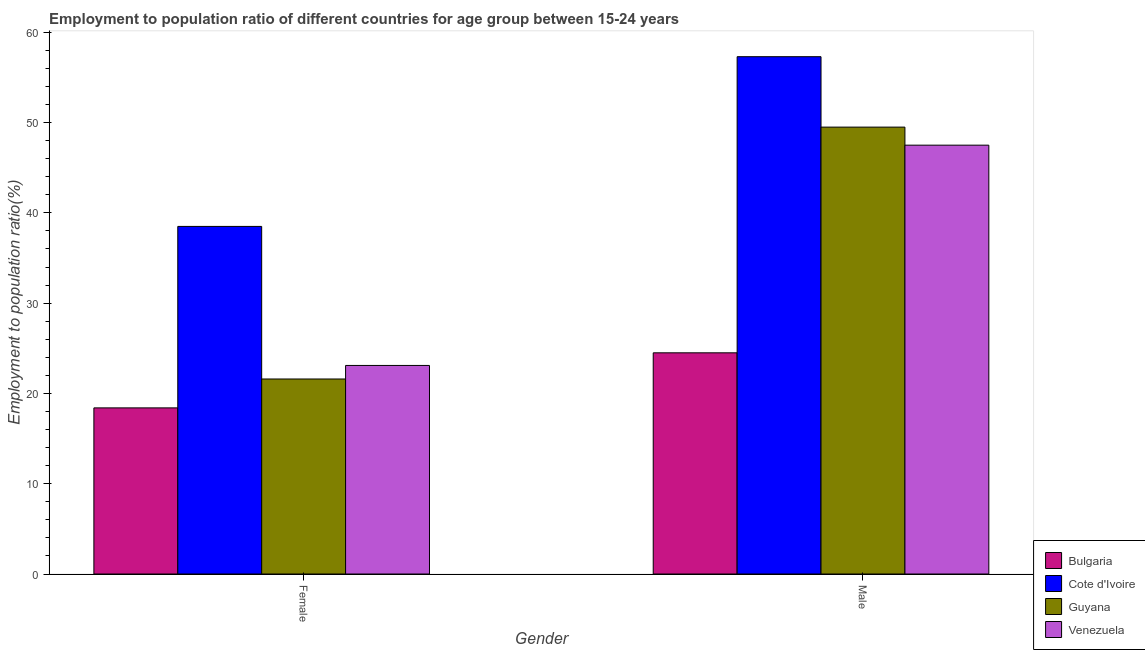How many different coloured bars are there?
Your response must be concise. 4. What is the label of the 2nd group of bars from the left?
Ensure brevity in your answer.  Male. What is the employment to population ratio(female) in Cote d'Ivoire?
Your response must be concise. 38.5. Across all countries, what is the maximum employment to population ratio(female)?
Give a very brief answer. 38.5. In which country was the employment to population ratio(male) maximum?
Keep it short and to the point. Cote d'Ivoire. What is the total employment to population ratio(female) in the graph?
Ensure brevity in your answer.  101.6. What is the difference between the employment to population ratio(male) in Guyana and that in Venezuela?
Offer a terse response. 2. What is the difference between the employment to population ratio(male) in Venezuela and the employment to population ratio(female) in Guyana?
Make the answer very short. 25.9. What is the average employment to population ratio(female) per country?
Your answer should be compact. 25.4. What is the difference between the employment to population ratio(female) and employment to population ratio(male) in Bulgaria?
Ensure brevity in your answer.  -6.1. In how many countries, is the employment to population ratio(female) greater than 2 %?
Your answer should be compact. 4. What is the ratio of the employment to population ratio(female) in Bulgaria to that in Guyana?
Offer a very short reply. 0.85. What does the 4th bar from the left in Female represents?
Offer a terse response. Venezuela. What does the 3rd bar from the right in Male represents?
Provide a short and direct response. Cote d'Ivoire. How many bars are there?
Ensure brevity in your answer.  8. How many countries are there in the graph?
Keep it short and to the point. 4. What is the difference between two consecutive major ticks on the Y-axis?
Provide a succinct answer. 10. Are the values on the major ticks of Y-axis written in scientific E-notation?
Offer a very short reply. No. Where does the legend appear in the graph?
Give a very brief answer. Bottom right. What is the title of the graph?
Provide a succinct answer. Employment to population ratio of different countries for age group between 15-24 years. Does "East Asia (developing only)" appear as one of the legend labels in the graph?
Your answer should be compact. No. What is the label or title of the X-axis?
Your response must be concise. Gender. What is the Employment to population ratio(%) in Bulgaria in Female?
Your answer should be very brief. 18.4. What is the Employment to population ratio(%) of Cote d'Ivoire in Female?
Provide a short and direct response. 38.5. What is the Employment to population ratio(%) in Guyana in Female?
Make the answer very short. 21.6. What is the Employment to population ratio(%) in Venezuela in Female?
Your answer should be very brief. 23.1. What is the Employment to population ratio(%) in Cote d'Ivoire in Male?
Your answer should be very brief. 57.3. What is the Employment to population ratio(%) in Guyana in Male?
Ensure brevity in your answer.  49.5. What is the Employment to population ratio(%) of Venezuela in Male?
Provide a short and direct response. 47.5. Across all Gender, what is the maximum Employment to population ratio(%) in Bulgaria?
Keep it short and to the point. 24.5. Across all Gender, what is the maximum Employment to population ratio(%) in Cote d'Ivoire?
Your response must be concise. 57.3. Across all Gender, what is the maximum Employment to population ratio(%) in Guyana?
Offer a terse response. 49.5. Across all Gender, what is the maximum Employment to population ratio(%) in Venezuela?
Provide a short and direct response. 47.5. Across all Gender, what is the minimum Employment to population ratio(%) in Bulgaria?
Provide a succinct answer. 18.4. Across all Gender, what is the minimum Employment to population ratio(%) of Cote d'Ivoire?
Ensure brevity in your answer.  38.5. Across all Gender, what is the minimum Employment to population ratio(%) of Guyana?
Your answer should be compact. 21.6. Across all Gender, what is the minimum Employment to population ratio(%) of Venezuela?
Provide a succinct answer. 23.1. What is the total Employment to population ratio(%) in Bulgaria in the graph?
Provide a short and direct response. 42.9. What is the total Employment to population ratio(%) in Cote d'Ivoire in the graph?
Offer a terse response. 95.8. What is the total Employment to population ratio(%) in Guyana in the graph?
Your response must be concise. 71.1. What is the total Employment to population ratio(%) in Venezuela in the graph?
Give a very brief answer. 70.6. What is the difference between the Employment to population ratio(%) in Bulgaria in Female and that in Male?
Provide a succinct answer. -6.1. What is the difference between the Employment to population ratio(%) in Cote d'Ivoire in Female and that in Male?
Your answer should be compact. -18.8. What is the difference between the Employment to population ratio(%) of Guyana in Female and that in Male?
Give a very brief answer. -27.9. What is the difference between the Employment to population ratio(%) in Venezuela in Female and that in Male?
Offer a terse response. -24.4. What is the difference between the Employment to population ratio(%) of Bulgaria in Female and the Employment to population ratio(%) of Cote d'Ivoire in Male?
Keep it short and to the point. -38.9. What is the difference between the Employment to population ratio(%) of Bulgaria in Female and the Employment to population ratio(%) of Guyana in Male?
Offer a very short reply. -31.1. What is the difference between the Employment to population ratio(%) of Bulgaria in Female and the Employment to population ratio(%) of Venezuela in Male?
Give a very brief answer. -29.1. What is the difference between the Employment to population ratio(%) of Guyana in Female and the Employment to population ratio(%) of Venezuela in Male?
Offer a very short reply. -25.9. What is the average Employment to population ratio(%) in Bulgaria per Gender?
Offer a very short reply. 21.45. What is the average Employment to population ratio(%) of Cote d'Ivoire per Gender?
Your answer should be very brief. 47.9. What is the average Employment to population ratio(%) of Guyana per Gender?
Make the answer very short. 35.55. What is the average Employment to population ratio(%) of Venezuela per Gender?
Your answer should be very brief. 35.3. What is the difference between the Employment to population ratio(%) of Bulgaria and Employment to population ratio(%) of Cote d'Ivoire in Female?
Ensure brevity in your answer.  -20.1. What is the difference between the Employment to population ratio(%) in Bulgaria and Employment to population ratio(%) in Venezuela in Female?
Make the answer very short. -4.7. What is the difference between the Employment to population ratio(%) in Cote d'Ivoire and Employment to population ratio(%) in Venezuela in Female?
Provide a short and direct response. 15.4. What is the difference between the Employment to population ratio(%) of Bulgaria and Employment to population ratio(%) of Cote d'Ivoire in Male?
Keep it short and to the point. -32.8. What is the difference between the Employment to population ratio(%) in Bulgaria and Employment to population ratio(%) in Venezuela in Male?
Provide a succinct answer. -23. What is the difference between the Employment to population ratio(%) of Cote d'Ivoire and Employment to population ratio(%) of Guyana in Male?
Make the answer very short. 7.8. What is the difference between the Employment to population ratio(%) in Cote d'Ivoire and Employment to population ratio(%) in Venezuela in Male?
Provide a short and direct response. 9.8. What is the ratio of the Employment to population ratio(%) in Bulgaria in Female to that in Male?
Offer a terse response. 0.75. What is the ratio of the Employment to population ratio(%) of Cote d'Ivoire in Female to that in Male?
Your response must be concise. 0.67. What is the ratio of the Employment to population ratio(%) of Guyana in Female to that in Male?
Offer a terse response. 0.44. What is the ratio of the Employment to population ratio(%) of Venezuela in Female to that in Male?
Provide a short and direct response. 0.49. What is the difference between the highest and the second highest Employment to population ratio(%) of Bulgaria?
Ensure brevity in your answer.  6.1. What is the difference between the highest and the second highest Employment to population ratio(%) in Cote d'Ivoire?
Give a very brief answer. 18.8. What is the difference between the highest and the second highest Employment to population ratio(%) of Guyana?
Ensure brevity in your answer.  27.9. What is the difference between the highest and the second highest Employment to population ratio(%) of Venezuela?
Your response must be concise. 24.4. What is the difference between the highest and the lowest Employment to population ratio(%) of Bulgaria?
Provide a short and direct response. 6.1. What is the difference between the highest and the lowest Employment to population ratio(%) in Guyana?
Make the answer very short. 27.9. What is the difference between the highest and the lowest Employment to population ratio(%) of Venezuela?
Provide a succinct answer. 24.4. 